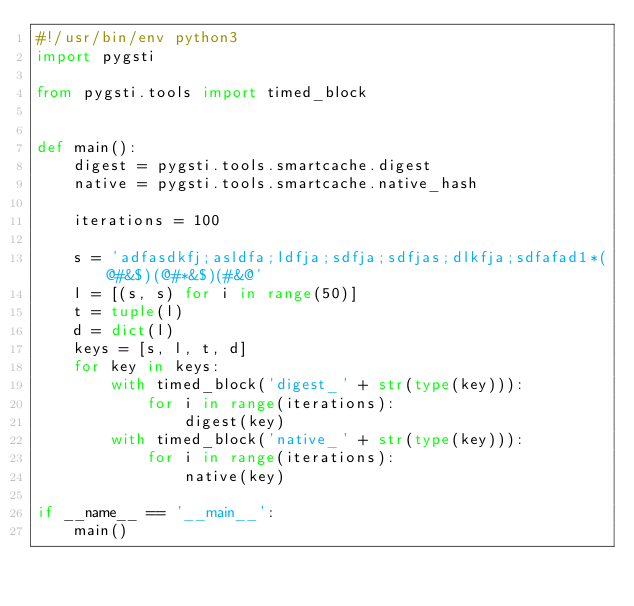Convert code to text. <code><loc_0><loc_0><loc_500><loc_500><_Python_>#!/usr/bin/env python3
import pygsti

from pygsti.tools import timed_block


def main():
    digest = pygsti.tools.smartcache.digest
    native = pygsti.tools.smartcache.native_hash

    iterations = 100

    s = 'adfasdkfj;asldfa;ldfja;sdfja;sdfjas;dlkfja;sdfafad1*(@#&$)(@#*&$)(#&@'
    l = [(s, s) for i in range(50)]
    t = tuple(l)
    d = dict(l)
    keys = [s, l, t, d]
    for key in keys:
        with timed_block('digest_' + str(type(key))):
            for i in range(iterations):
                digest(key)
        with timed_block('native_' + str(type(key))):
            for i in range(iterations):
                native(key)

if __name__ == '__main__':
    main()
</code> 